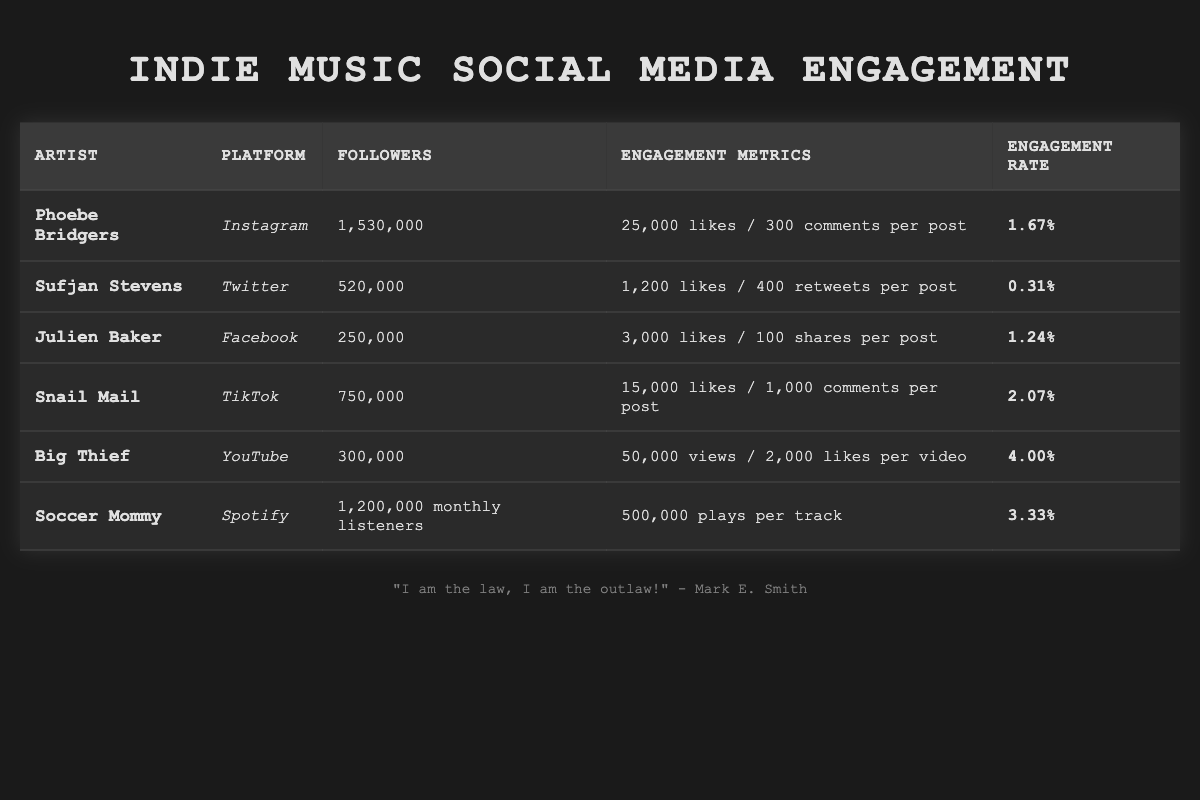What is the highest engagement rate among the artists listed? By examining the engagement rates in the table, I can see that Big Thief has the highest engagement rate at 4.00%.
Answer: 4.00% Which artist has the most followers and on which platform? The table shows that Phoebe Bridgers has the most followers with 1,530,000 on Instagram.
Answer: Phoebe Bridgers on Instagram How many likes per post does Snail Mail typically receive? According to the table, Snail Mail receives an average of 15,000 likes per post on TikTok.
Answer: 15,000 What is the engagement rate of Soccer Mommy? The engagement rate for Soccer Mommy is listed as 3.33% in the table.
Answer: 3.33% Which artist has a higher engagement rate, Sufjan Stevens or Julien Baker? Sufjan Stevens has an engagement rate of 0.31%, while Julien Baker's is 1.24%. Julien Baker has the higher rate.
Answer: Julien Baker What is the total number of followers for artists on Instagram and TikTok combined? For Phoebe Bridgers on Instagram, there are 1,530,000 followers and for Snail Mail on TikTok, there are 750,000 followers. Adding these gives 1,530,000 + 750,000 = 2,280,000.
Answer: 2,280,000 How many average likes per post does Soccer Mommy have if it is compared to the likes per post of Phoebe Bridgers? Phoebe Bridgers has 25,000 likes per post, while Soccer Mommy's post engagement is not listed but has an engagement rate of 3.33%. Since likes per post is not provided for Soccer Mommy, we cannot make a valid comparison based on the table data.
Answer: Cannot compare Name the artist with the least number of followers and their platform. The artist with the least number of followers is Julien Baker with 250,000 on Facebook.
Answer: Julien Baker on Facebook What is the difference in engagement rate between Snail Mail and Big Thief? Snail Mail has an engagement rate of 2.07%, while Big Thief has an engagement rate of 4.00%. The difference is 4.00% - 2.07% = 1.93%.
Answer: 1.93% Does any artist on the list have an engagement rate above 2%? Yes, Snail Mail (2.07%), Big Thief (4.00%), and Soccer Mommy (3.33%) all have engagement rates above 2%.
Answer: Yes 